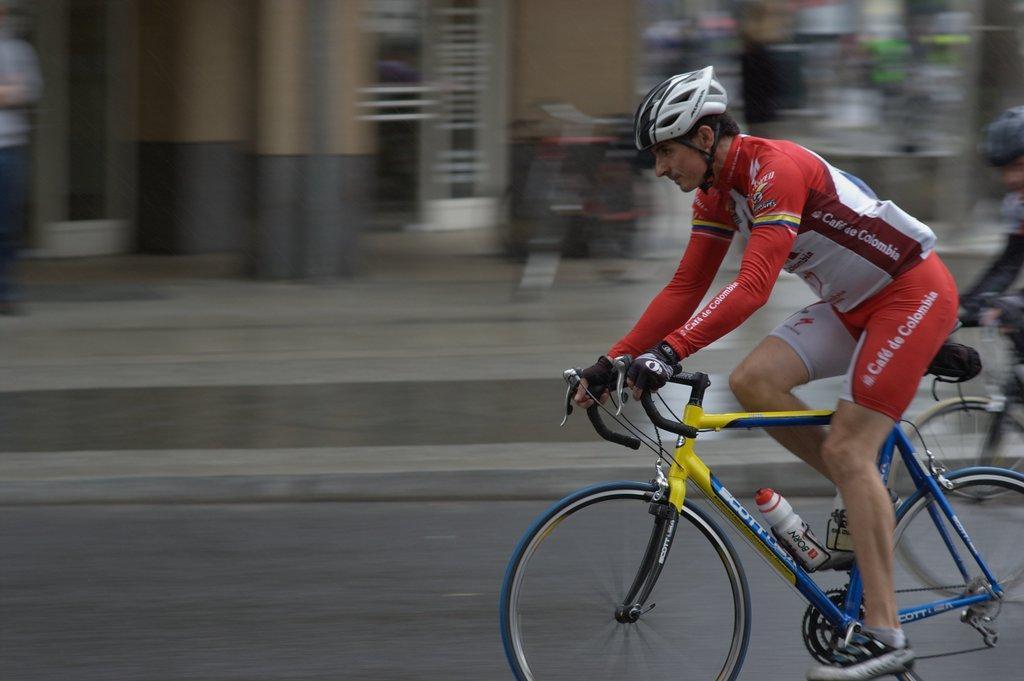Please provide a concise description of this image. On the right side of the image, we can see a person is riding a bicycle. Background we can see the blur view. Here we can see road, walkway, walls and few objects. On the right side and left side of the we can see people. 